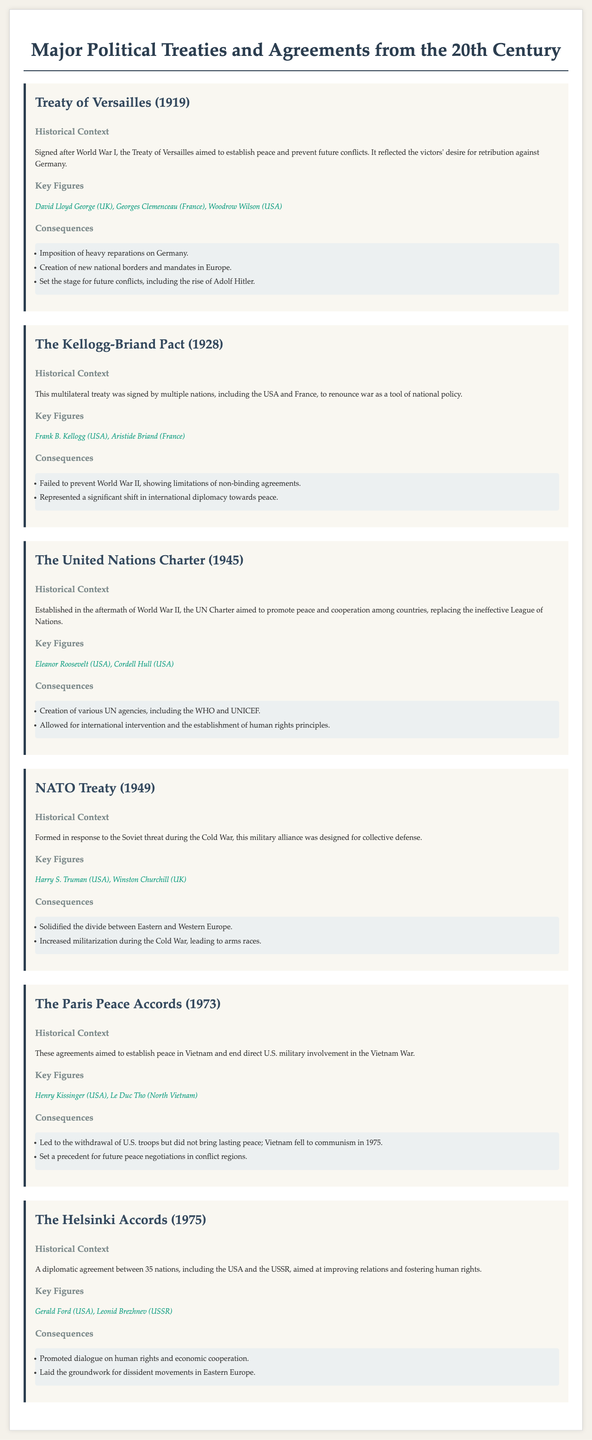What year was the Treaty of Versailles signed? The Treaty of Versailles was signed in 1919, according to the document.
Answer: 1919 Who was a key figure in the Kellogg-Briand Pact? The document lists Frank B. Kellogg as a key figure in the Kellogg-Briand Pact.
Answer: Frank B. Kellogg What is a consequence of the United Nations Charter? One consequence mentioned is the creation of various UN agencies, including the WHO and UNICEF.
Answer: Creation of various UN agencies What was the primary aim of NATO when it was formed? The document states that NATO was designed for collective defense against the Soviet threat.
Answer: Collective defense Who were the key figures involved in the Paris Peace Accords? The key figures in the Paris Peace Accords were Henry Kissinger and Le Duc Tho, as stated in the document.
Answer: Henry Kissinger, Le Duc Tho What was a significant outcome of the Helsinki Accords? The document mentions that they promoted dialogue on human rights and economic cooperation as a significant outcome.
Answer: Promoted dialogue on human rights What major conflict did the Treaty of Versailles aim to resolve? The Treaty of Versailles aimed to establish peace after World War I.
Answer: World War I Which treaty aimed to end U.S. military involvement in the Vietnam War? The Paris Peace Accords aimed to end direct U.S. military involvement in the Vietnam War.
Answer: The Paris Peace Accords 